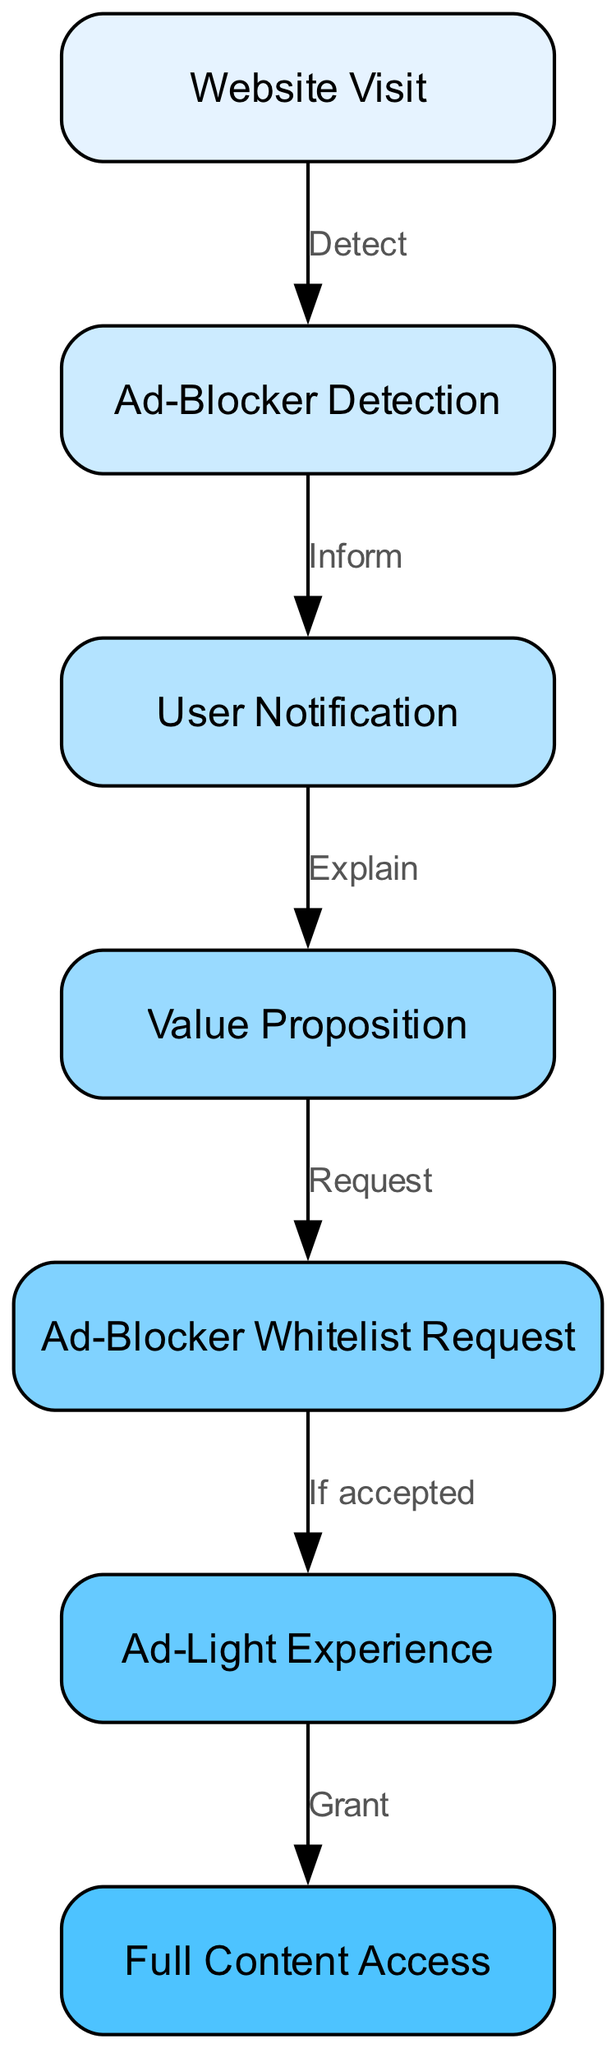What is the first node in the diagram? The first node is "Website Visit," which is at the top of the diagram. It is the entry point for users into the engagement funnel.
Answer: Website Visit How many total nodes are in this diagram? Counting all the distinct nodes listed, there are seven nodes represented in the diagram.
Answer: 7 What does the "Ad-Blocker Detection" node do? This node is responsible for detecting if a user has an ad-blocker enabled when they visit the website, which is the first step after the "Website Visit."
Answer: Detects ad-blocker What is the relationship between "User Notification" and "Value Proposition"? The "User Notification" node informs users about the presence of an ad-blocker and leads them to the "Value Proposition" node, where the website explains what users will gain by whitelisting ads.
Answer: Inform, Explain What happens if the user accepts the "Ad-Blocker Whitelist Request"? If the user accepts the request to whitelist ads, they are granted access to the "Ad-Light Experience," which indicates a lighter ad experience on the site.
Answer: Ad-Light Experience What is the connection between "Value Proposition" and "Ad-Blocker Whitelist Request"? The "Value Proposition" node requests users to whitelist ads, presenting them with a compelling reason to do so after explaining the value they would get in return.
Answer: Request How many edges are present in the diagram? By counting the connections (edges) between the nodes, there are six edges that illustrate the flow from one node to the next in the engagement funnel.
Answer: 6 What does "Ad-Light Experience" lead to? The "Ad-Light Experience" node grants users "Full Content Access," meaning users who whitelist ads will have no restrictions on accessing content.
Answer: Full Content Access What is the purpose of the entire engagement funnel depicted in the diagram? The engagement funnel aims to reduce ad-blocker usage by guiding users from detection, through notification, to acceptance of ads in exchange for value.
Answer: Reduce ad-blocker usage 